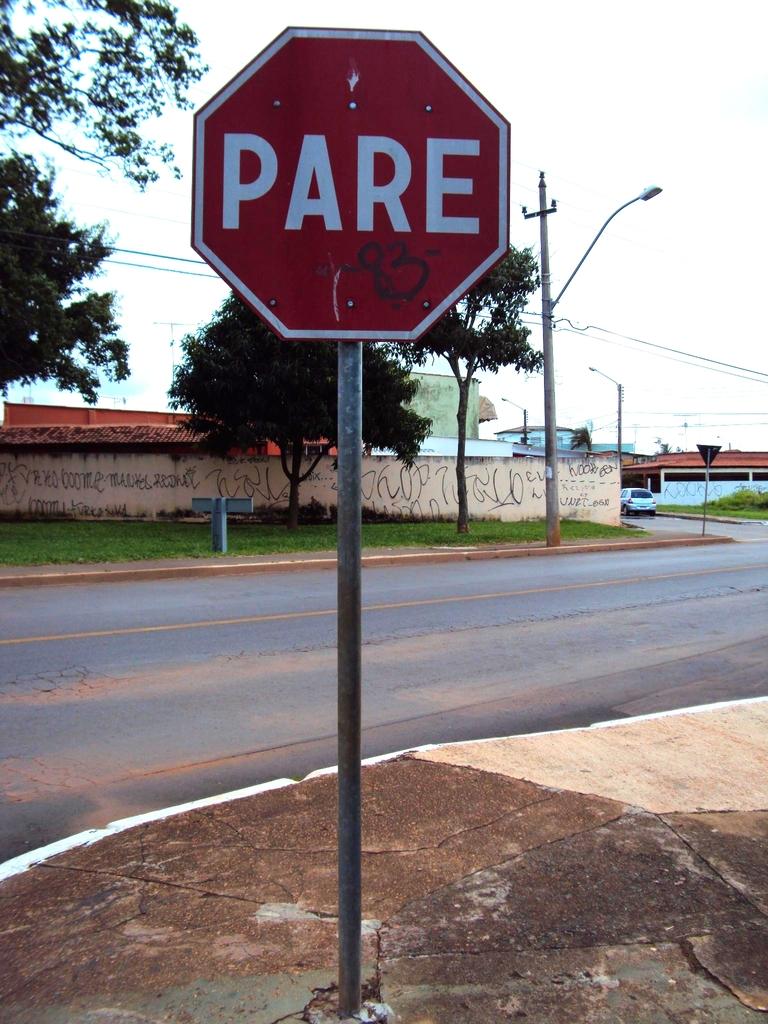What does the sign say?
Ensure brevity in your answer.  Pare. What is the number sprayed painted on the sign?
Make the answer very short. 83. 